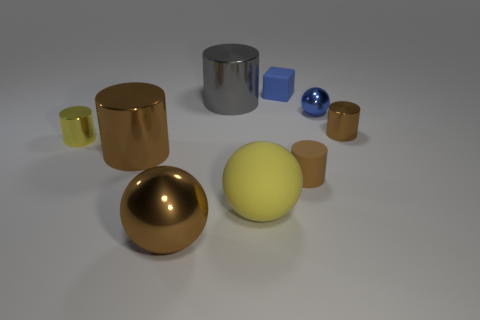Subtract all large gray metallic cylinders. How many cylinders are left? 4 Add 1 large brown balls. How many objects exist? 10 Subtract 3 cylinders. How many cylinders are left? 2 Subtract all blocks. How many objects are left? 8 Subtract all blue cubes. How many brown cylinders are left? 3 Subtract all gray cylinders. Subtract all gray spheres. How many cylinders are left? 4 Subtract all big matte balls. Subtract all large yellow matte things. How many objects are left? 7 Add 3 blue balls. How many blue balls are left? 4 Add 4 blue metal things. How many blue metal things exist? 5 Subtract all yellow spheres. How many spheres are left? 2 